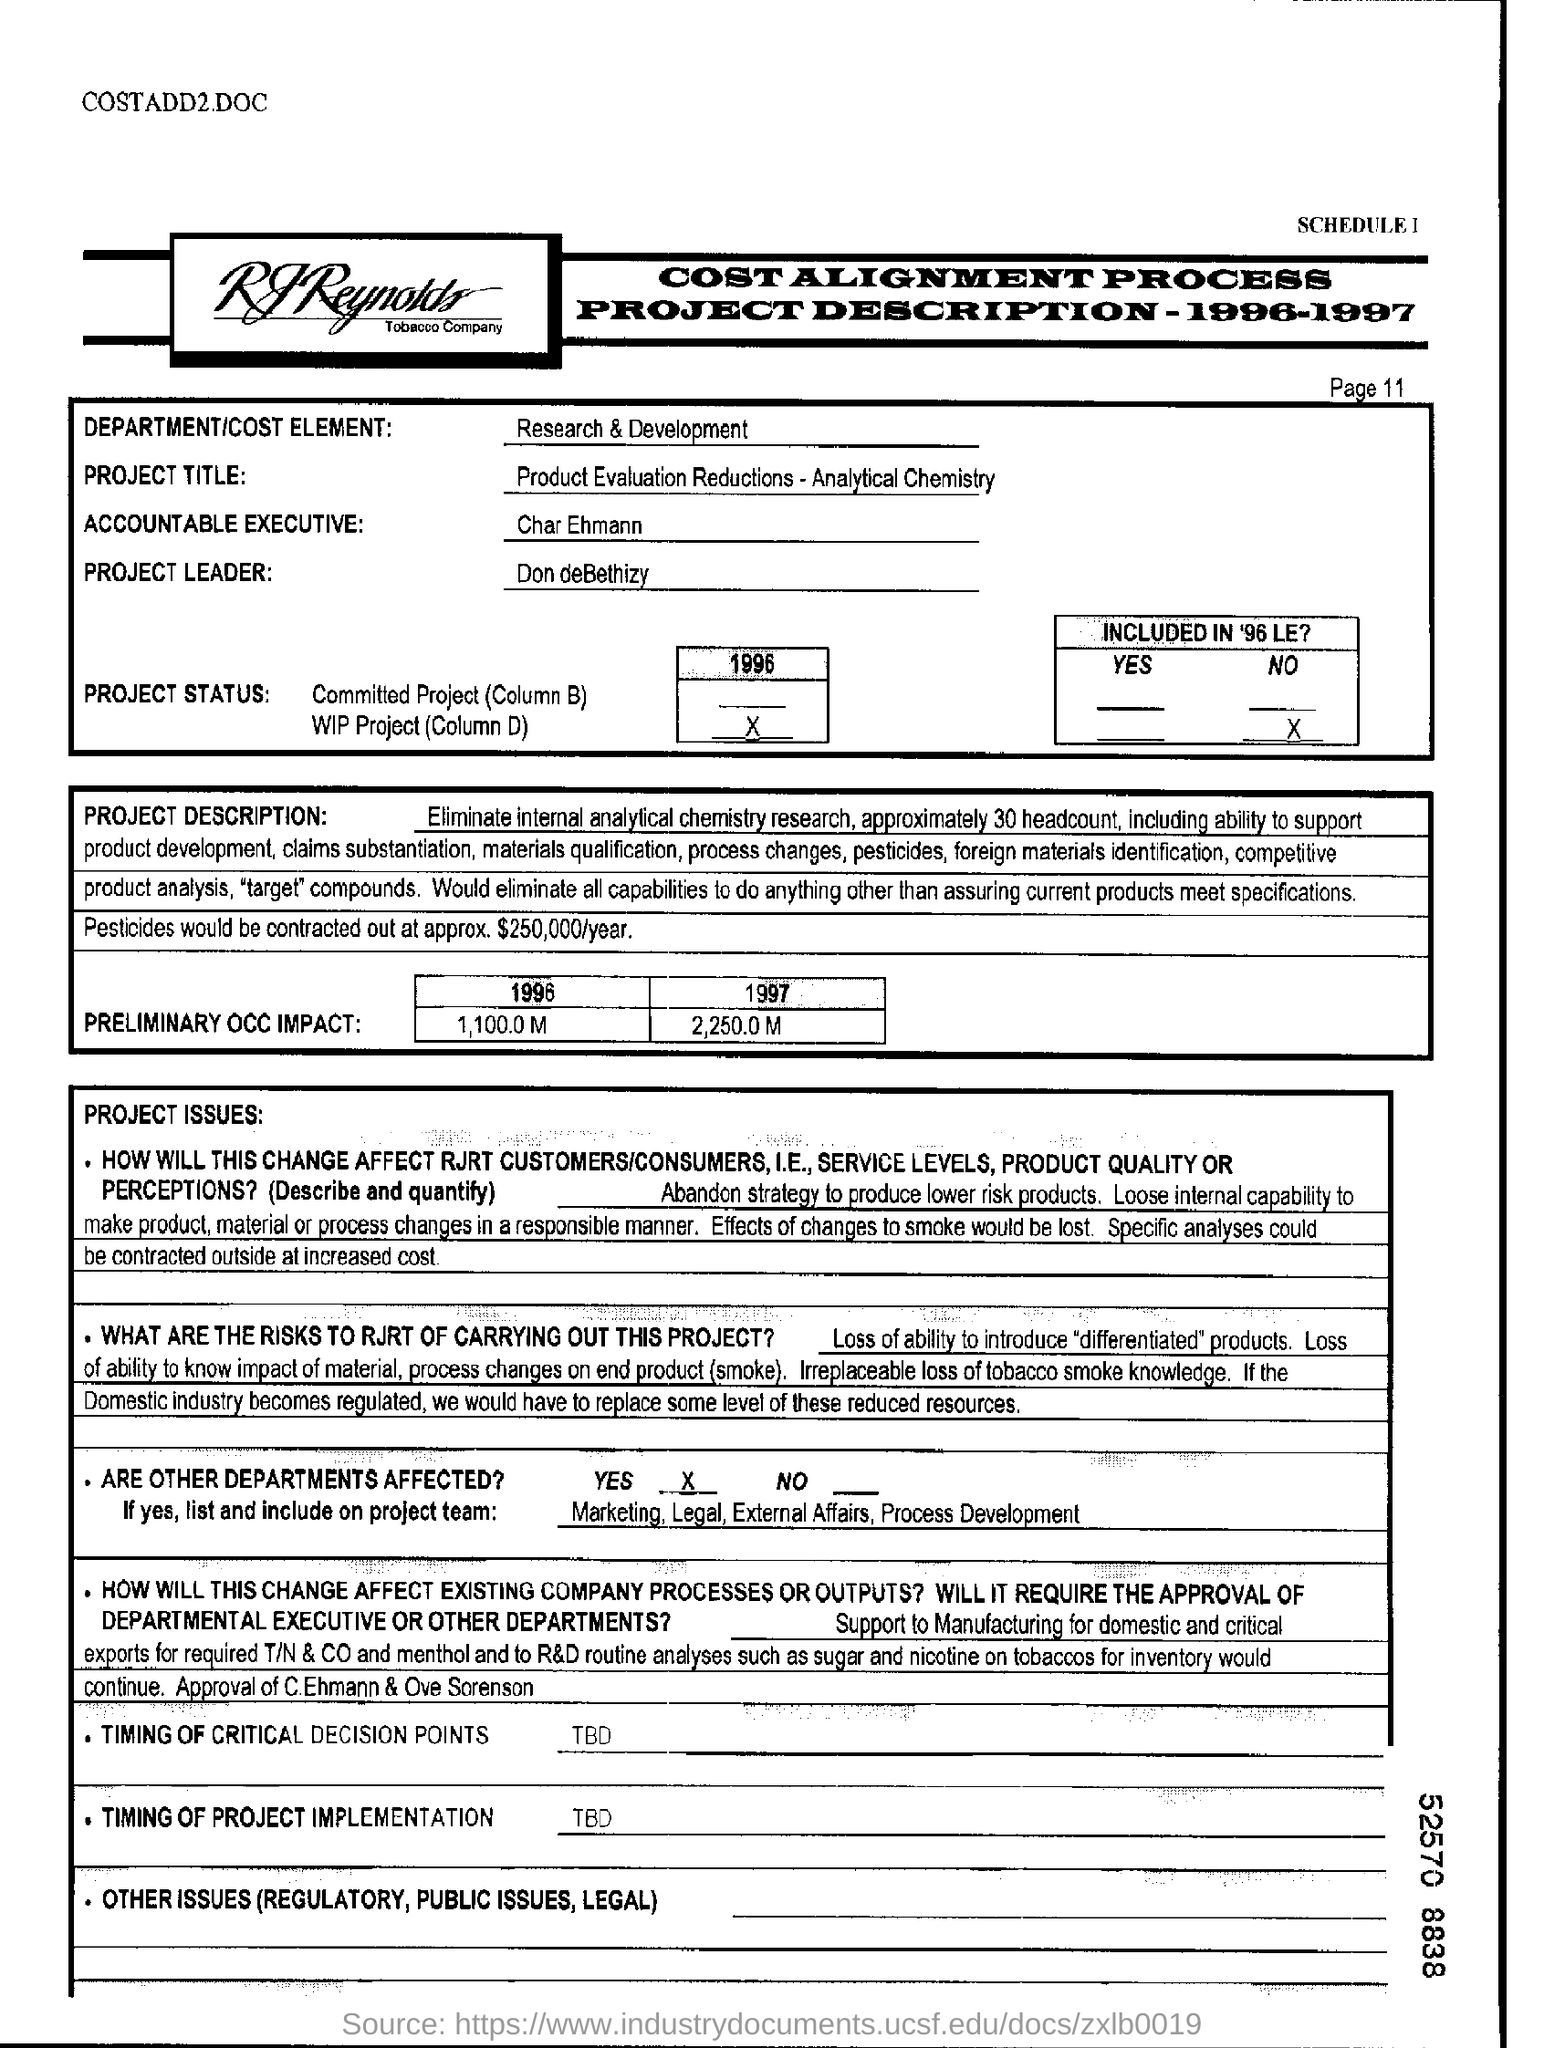Mention a couple of crucial points in this snapshot. The accountable executive is Char Ehmann. The marketing, legal, external affairs, and process development departments are also affected by the COVID-19 pandemic. The project is titled 'Product Evaluation Reductions- Analytical Chemistry'. Don deBethizy is the project leader with a designation. The department/cost element in question is research & development. 